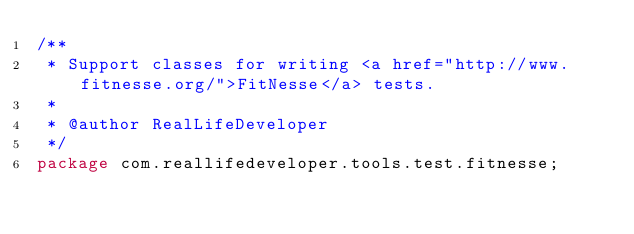Convert code to text. <code><loc_0><loc_0><loc_500><loc_500><_Java_>/**
 * Support classes for writing <a href="http://www.fitnesse.org/">FitNesse</a> tests.
 *
 * @author RealLifeDeveloper
 */
package com.reallifedeveloper.tools.test.fitnesse;
</code> 